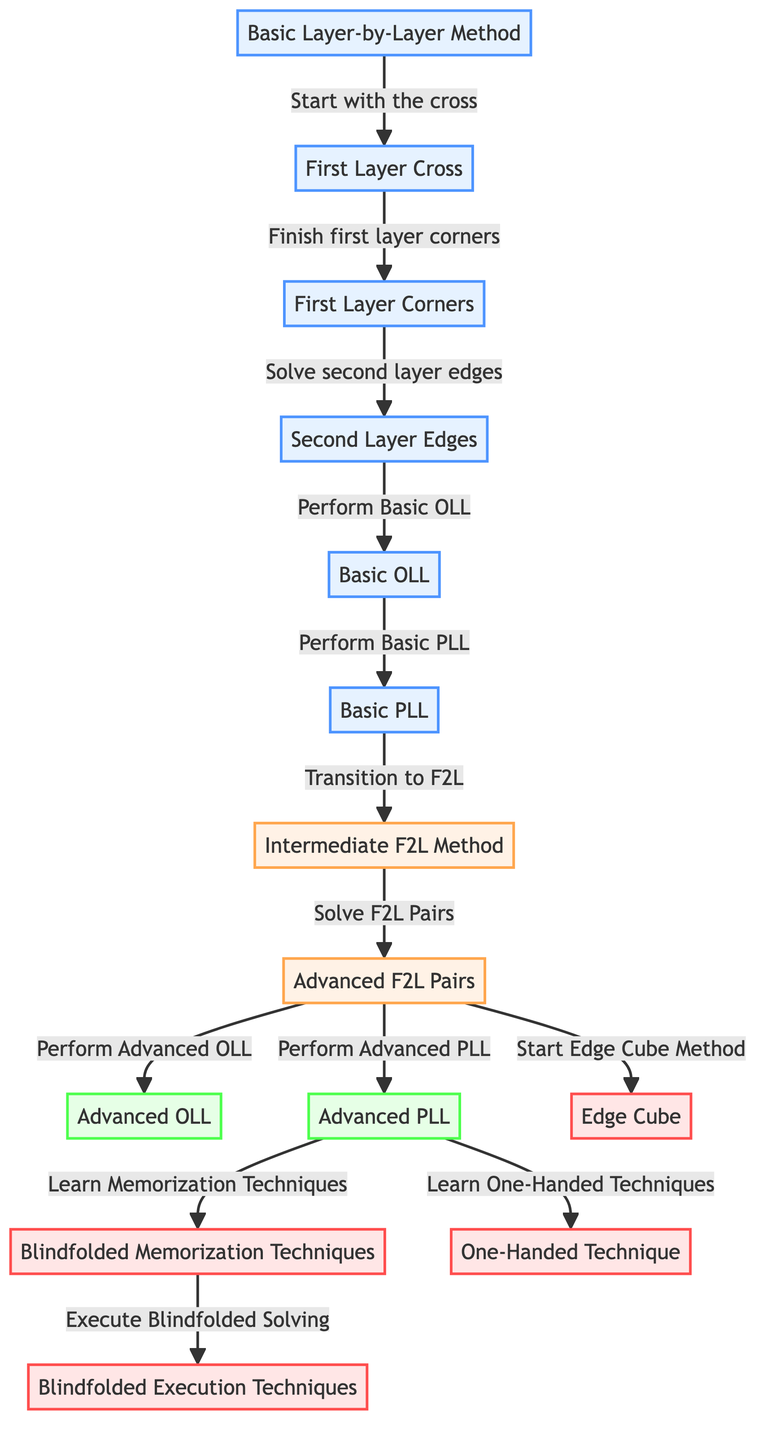What is the starting method in the diagram? The diagram indicates that the basic layer-by-layer method is the starting point. It's labeled as "start" and has a clear connection flowing into the first step.
Answer: Basic Layer-by-Layer Method How many nodes represent the basic solving techniques? The diagram has five nodes that are classified under basic techniques, from the starting method to the Basic PLL. These are listed sequentially and connect directly to an intermediate method.
Answer: Five Which method comes after the Basic PLL in the flowchart? Following the Basic PLL, the flow leads to the intermediate F2L method, which is indicated as "intermediate" and serves as a transition to more advanced techniques.
Answer: Intermediate F2L Method What are the two advanced techniques you can learn after Advanced PLL? After the Advanced PLL, you can learn Blindfolded Memorization Techniques and One-Handed Techniques as indicated by the outgoing connections from Advanced PLL.
Answer: Blindfolded Memorization Techniques and One-Handed Techniques Is the Edge Cube considered a basic or advanced technique? The Edge Cube method is categorized as a special technique, which is distinct from basic or advanced techniques as it has its own unique labeling in the diagram.
Answer: Special How many edges lead from the Intermediate F2L Method? There are three edges leading from the Intermediate F2L Method, each representing different advanced solving methods or techniques that can be explored subsequently.
Answer: Three What connecting node leads into Advanced OLL? From the Intermediate F2L Method, there is a direct edge leading to Advanced OLL, indicating this is a step in the process towards more advanced algorithms.
Answer: Intermediate F2L Method Which technique focuses on memorization for blindfolded solving? The technique focusing on memorization for blindfolded solving is specifically referred to as "Blindfolded Memorization Techniques" in the diagram, showing its role in advanced solving.
Answer: Blindfolded Memorization Techniques What visual representation denotes the transition from basic to advanced techniques? The diagram uses arrows to visually represent connections between the basic layer-by-layer method and the subsequent advanced techniques, illustrating the flow of learning.
Answer: Arrows connecting nodes 